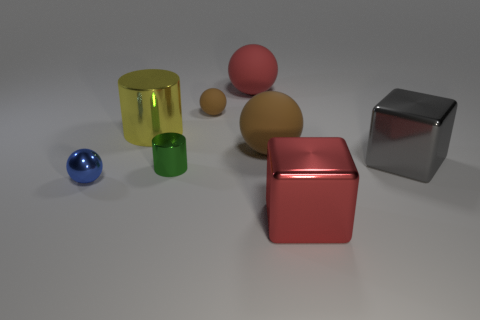How many small metal objects are behind the tiny blue ball?
Ensure brevity in your answer.  1. What is the size of the object that is the same color as the small rubber ball?
Offer a terse response. Large. Is there another big yellow matte object of the same shape as the big yellow object?
Offer a very short reply. No. The other shiny thing that is the same size as the green shiny object is what color?
Provide a short and direct response. Blue. Are there fewer green things on the right side of the gray block than shiny objects on the left side of the red ball?
Your answer should be very brief. Yes. Do the brown ball right of the red rubber ball and the green thing have the same size?
Your answer should be compact. No. What is the shape of the big matte object that is in front of the red sphere?
Ensure brevity in your answer.  Sphere. Are there more big red metal things than brown cylinders?
Your answer should be compact. Yes. Do the matte object that is on the right side of the big red matte object and the tiny rubber thing have the same color?
Keep it short and to the point. Yes. What number of things are either small spheres behind the gray metal block or things behind the big brown thing?
Offer a very short reply. 3. 